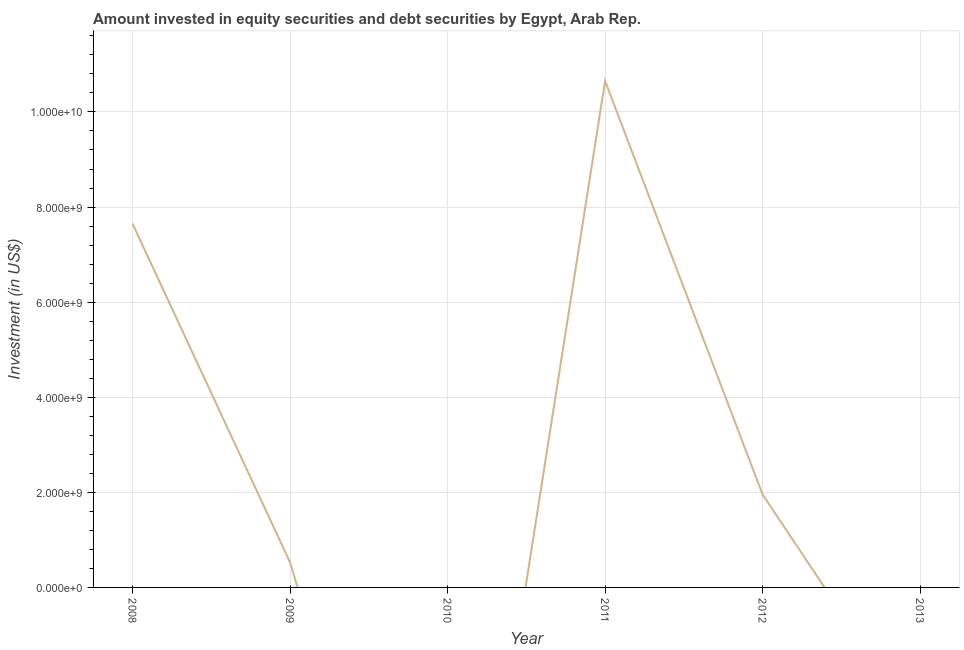What is the portfolio investment in 2010?
Offer a very short reply. 0. Across all years, what is the maximum portfolio investment?
Give a very brief answer. 1.07e+1. Across all years, what is the minimum portfolio investment?
Keep it short and to the point. 0. In which year was the portfolio investment maximum?
Make the answer very short. 2011. What is the sum of the portfolio investment?
Make the answer very short. 2.08e+1. What is the difference between the portfolio investment in 2011 and 2012?
Give a very brief answer. 8.70e+09. What is the average portfolio investment per year?
Give a very brief answer. 3.46e+09. What is the median portfolio investment?
Keep it short and to the point. 1.24e+09. In how many years, is the portfolio investment greater than 10400000000 US$?
Keep it short and to the point. 1. What is the ratio of the portfolio investment in 2008 to that in 2012?
Make the answer very short. 3.92. Is the portfolio investment in 2008 less than that in 2009?
Give a very brief answer. No. What is the difference between the highest and the second highest portfolio investment?
Provide a short and direct response. 3.00e+09. Is the sum of the portfolio investment in 2008 and 2011 greater than the maximum portfolio investment across all years?
Your answer should be very brief. Yes. What is the difference between the highest and the lowest portfolio investment?
Provide a short and direct response. 1.07e+1. In how many years, is the portfolio investment greater than the average portfolio investment taken over all years?
Your answer should be compact. 2. Does the portfolio investment monotonically increase over the years?
Provide a succinct answer. No. How many lines are there?
Your response must be concise. 1. How many years are there in the graph?
Your answer should be very brief. 6. What is the difference between two consecutive major ticks on the Y-axis?
Ensure brevity in your answer.  2.00e+09. Are the values on the major ticks of Y-axis written in scientific E-notation?
Provide a succinct answer. Yes. Does the graph contain grids?
Provide a succinct answer. Yes. What is the title of the graph?
Your response must be concise. Amount invested in equity securities and debt securities by Egypt, Arab Rep. What is the label or title of the Y-axis?
Your answer should be very brief. Investment (in US$). What is the Investment (in US$) of 2008?
Offer a terse response. 7.65e+09. What is the Investment (in US$) of 2009?
Provide a short and direct response. 5.27e+08. What is the Investment (in US$) of 2011?
Offer a terse response. 1.07e+1. What is the Investment (in US$) in 2012?
Give a very brief answer. 1.95e+09. What is the difference between the Investment (in US$) in 2008 and 2009?
Your answer should be compact. 7.12e+09. What is the difference between the Investment (in US$) in 2008 and 2011?
Keep it short and to the point. -3.00e+09. What is the difference between the Investment (in US$) in 2008 and 2012?
Provide a short and direct response. 5.70e+09. What is the difference between the Investment (in US$) in 2009 and 2011?
Keep it short and to the point. -1.01e+1. What is the difference between the Investment (in US$) in 2009 and 2012?
Keep it short and to the point. -1.43e+09. What is the difference between the Investment (in US$) in 2011 and 2012?
Provide a short and direct response. 8.70e+09. What is the ratio of the Investment (in US$) in 2008 to that in 2009?
Make the answer very short. 14.51. What is the ratio of the Investment (in US$) in 2008 to that in 2011?
Make the answer very short. 0.72. What is the ratio of the Investment (in US$) in 2008 to that in 2012?
Offer a very short reply. 3.92. What is the ratio of the Investment (in US$) in 2009 to that in 2011?
Your answer should be compact. 0.05. What is the ratio of the Investment (in US$) in 2009 to that in 2012?
Make the answer very short. 0.27. What is the ratio of the Investment (in US$) in 2011 to that in 2012?
Make the answer very short. 5.45. 